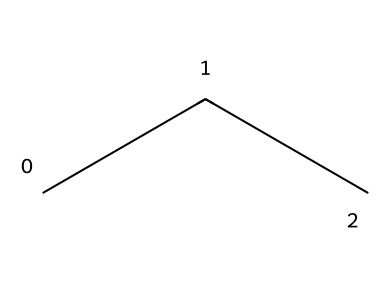What is the molecular formula of propane? The molecular formula is derived from the count of carbon and hydrogen atoms in the structure. Propane has three carbon atoms and eight hydrogen atoms. Thus, the molecular formula is C3H8.
Answer: C3H8 How many carbon atoms are in propane? By analyzing the structural representation, it is evident there are three distinct carbon atoms connected in a linear fashion.
Answer: 3 How many hydrogen atoms are bonded to each carbon atom in propane? In the structure of propane, each terminal carbon atom is bonded to three hydrogen atoms, while the central carbon atom is bonded to two hydrogen atoms, making a total of eight hydrogen atoms.
Answer: 8 Is propane a saturated or unsaturated compound? Propane is classified as a saturated compound because all carbon atoms have single bonds with hydrogen atoms, allowing it to contain the maximum number of hydrogen atoms.
Answer: saturated What type of hydrocarbon is propane categorized as? Propane is categorized as an aliphatic hydrocarbon because it consists of open-chain carbon atoms and does not contain aromatic properties such as ring structures.
Answer: aliphatic What is the boiling point of propane? The boiling point of propane is a specific physical property that can be referenced from its chemical characteristics, which is approximately -42 degrees Celsius.
Answer: -42 degrees Celsius 